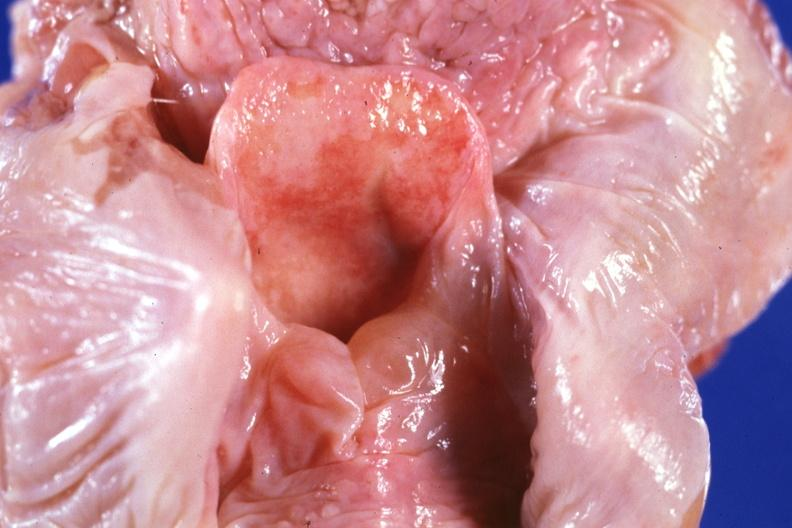where is this?
Answer the question using a single word or phrase. Oral 